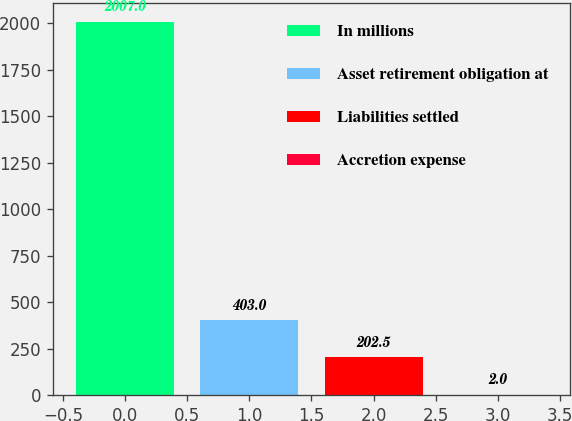<chart> <loc_0><loc_0><loc_500><loc_500><bar_chart><fcel>In millions<fcel>Asset retirement obligation at<fcel>Liabilities settled<fcel>Accretion expense<nl><fcel>2007<fcel>403<fcel>202.5<fcel>2<nl></chart> 